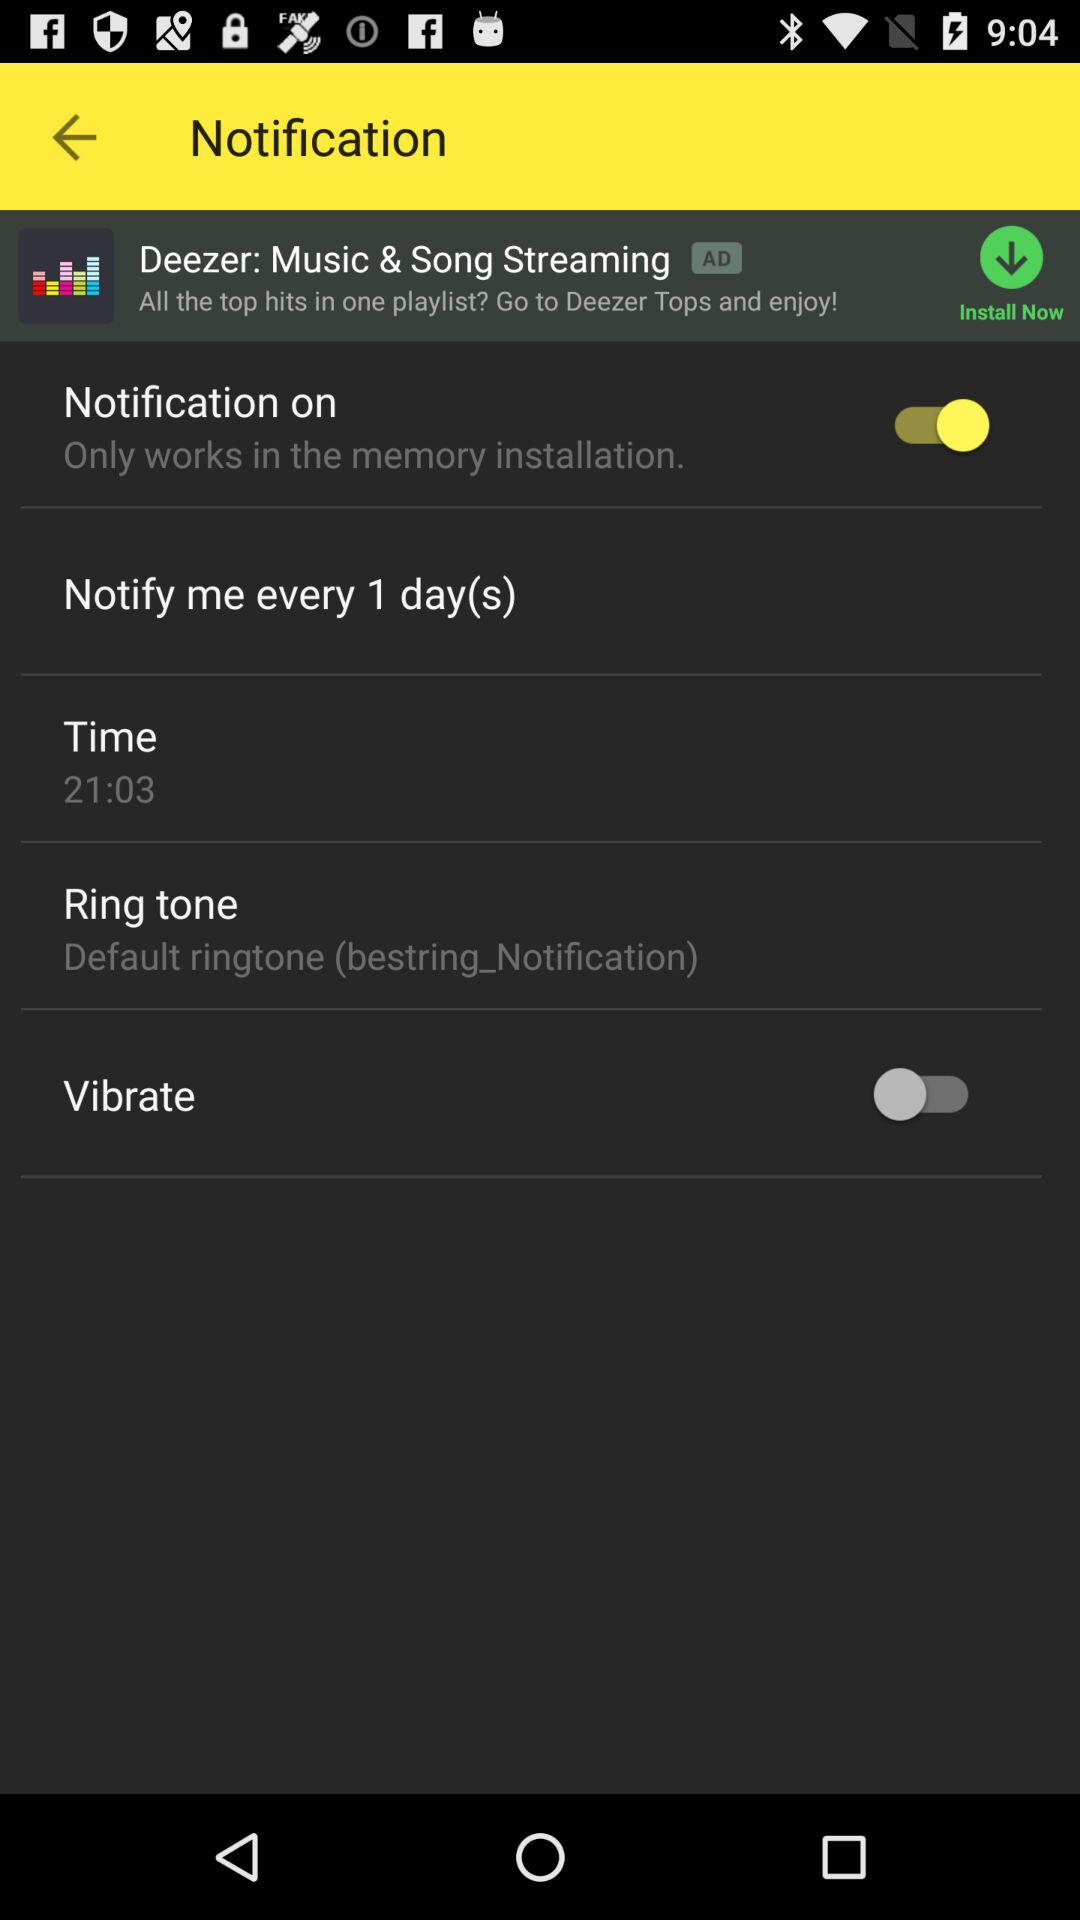What is the default ringtone for notification? The default ringtone is "bestring_Notification". 